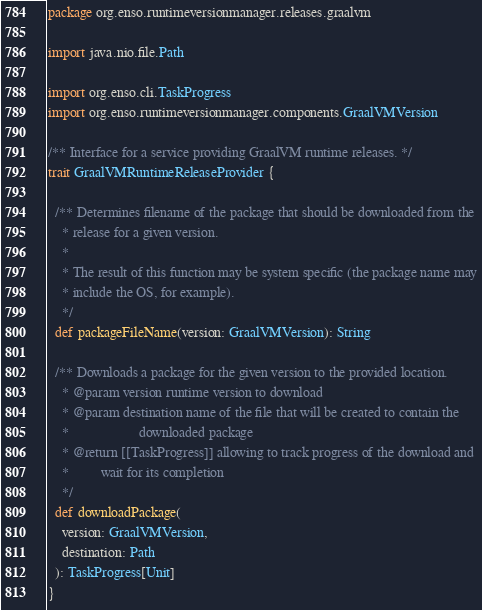<code> <loc_0><loc_0><loc_500><loc_500><_Scala_>package org.enso.runtimeversionmanager.releases.graalvm

import java.nio.file.Path

import org.enso.cli.TaskProgress
import org.enso.runtimeversionmanager.components.GraalVMVersion

/** Interface for a service providing GraalVM runtime releases. */
trait GraalVMRuntimeReleaseProvider {

  /** Determines filename of the package that should be downloaded from the
    * release for a given version.
    *
    * The result of this function may be system specific (the package name may
    * include the OS, for example).
    */
  def packageFileName(version: GraalVMVersion): String

  /** Downloads a package for the given version to the provided location.
    * @param version runtime version to download
    * @param destination name of the file that will be created to contain the
    *                    downloaded package
    * @return [[TaskProgress]] allowing to track progress of the download and
    *         wait for its completion
    */
  def downloadPackage(
    version: GraalVMVersion,
    destination: Path
  ): TaskProgress[Unit]
}
</code> 